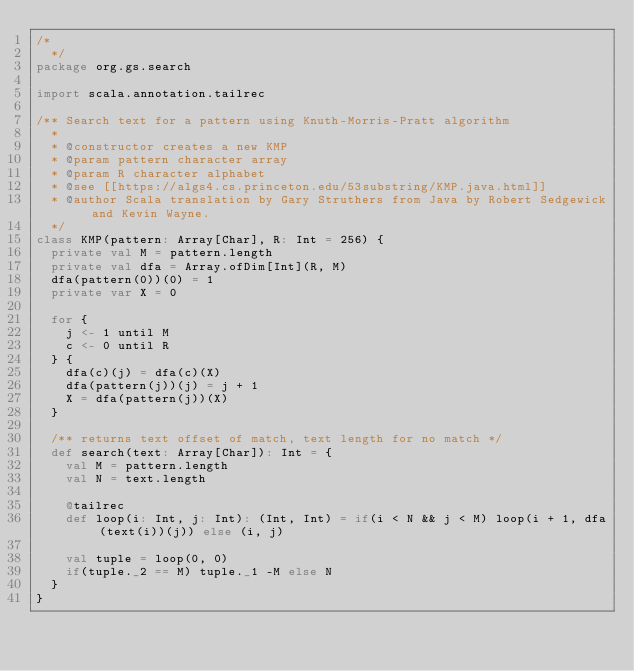Convert code to text. <code><loc_0><loc_0><loc_500><loc_500><_Scala_>/*
  */
package org.gs.search

import scala.annotation.tailrec

/** Search text for a pattern using Knuth-Morris-Pratt algorithm
  *
  * @constructor creates a new KMP
  * @param pattern character array
  * @param R character alphabet
  * @see [[https://algs4.cs.princeton.edu/53substring/KMP.java.html]]
  * @author Scala translation by Gary Struthers from Java by Robert Sedgewick and Kevin Wayne.
  */
class KMP(pattern: Array[Char], R: Int = 256) {
  private val M = pattern.length
  private val dfa = Array.ofDim[Int](R, M)
  dfa(pattern(0))(0) = 1
  private var X = 0

  for {
    j <- 1 until M
    c <- 0 until R
  } {
    dfa(c)(j) = dfa(c)(X)
    dfa(pattern(j))(j) = j + 1
    X = dfa(pattern(j))(X)
  }

  /** returns text offset of match, text length for no match */
  def search(text: Array[Char]): Int = {
    val M = pattern.length
    val N = text.length

    @tailrec
    def loop(i: Int, j: Int): (Int, Int) = if(i < N && j < M) loop(i + 1, dfa(text(i))(j)) else (i, j)

    val tuple = loop(0, 0)
    if(tuple._2 == M) tuple._1 -M else N
  }
}
</code> 